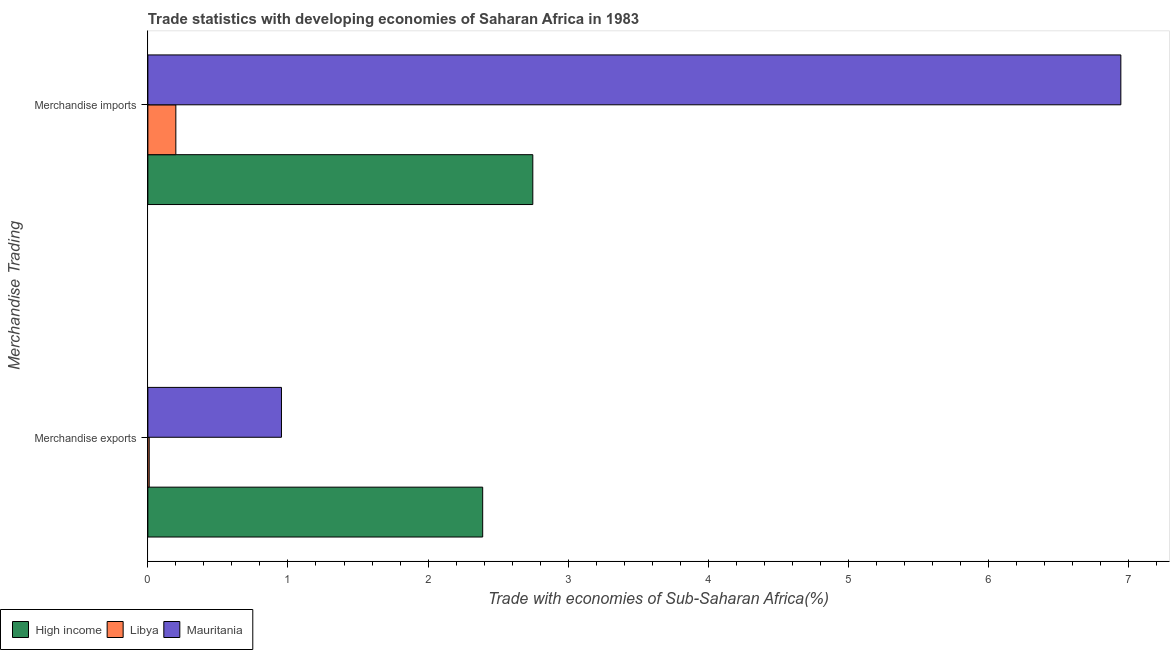How many groups of bars are there?
Give a very brief answer. 2. Are the number of bars per tick equal to the number of legend labels?
Give a very brief answer. Yes. Are the number of bars on each tick of the Y-axis equal?
Provide a succinct answer. Yes. How many bars are there on the 1st tick from the bottom?
Offer a terse response. 3. What is the merchandise imports in Libya?
Provide a short and direct response. 0.2. Across all countries, what is the maximum merchandise exports?
Make the answer very short. 2.39. Across all countries, what is the minimum merchandise exports?
Your answer should be very brief. 0.01. In which country was the merchandise exports maximum?
Offer a very short reply. High income. In which country was the merchandise imports minimum?
Ensure brevity in your answer.  Libya. What is the total merchandise exports in the graph?
Offer a very short reply. 3.35. What is the difference between the merchandise exports in Libya and that in Mauritania?
Provide a short and direct response. -0.94. What is the difference between the merchandise imports in High income and the merchandise exports in Libya?
Give a very brief answer. 2.74. What is the average merchandise exports per country?
Offer a very short reply. 1.12. What is the difference between the merchandise imports and merchandise exports in Libya?
Your answer should be compact. 0.19. In how many countries, is the merchandise imports greater than 2 %?
Provide a succinct answer. 2. What is the ratio of the merchandise imports in Mauritania to that in High income?
Keep it short and to the point. 2.53. In how many countries, is the merchandise imports greater than the average merchandise imports taken over all countries?
Your response must be concise. 1. What does the 3rd bar from the top in Merchandise imports represents?
Offer a very short reply. High income. What does the 2nd bar from the bottom in Merchandise exports represents?
Ensure brevity in your answer.  Libya. What is the difference between two consecutive major ticks on the X-axis?
Give a very brief answer. 1. Are the values on the major ticks of X-axis written in scientific E-notation?
Your answer should be very brief. No. Does the graph contain any zero values?
Ensure brevity in your answer.  No. Does the graph contain grids?
Your answer should be compact. No. What is the title of the graph?
Offer a very short reply. Trade statistics with developing economies of Saharan Africa in 1983. Does "Israel" appear as one of the legend labels in the graph?
Offer a terse response. No. What is the label or title of the X-axis?
Ensure brevity in your answer.  Trade with economies of Sub-Saharan Africa(%). What is the label or title of the Y-axis?
Give a very brief answer. Merchandise Trading. What is the Trade with economies of Sub-Saharan Africa(%) of High income in Merchandise exports?
Your response must be concise. 2.39. What is the Trade with economies of Sub-Saharan Africa(%) in Libya in Merchandise exports?
Your answer should be compact. 0.01. What is the Trade with economies of Sub-Saharan Africa(%) of Mauritania in Merchandise exports?
Your answer should be compact. 0.95. What is the Trade with economies of Sub-Saharan Africa(%) in High income in Merchandise imports?
Give a very brief answer. 2.75. What is the Trade with economies of Sub-Saharan Africa(%) in Libya in Merchandise imports?
Ensure brevity in your answer.  0.2. What is the Trade with economies of Sub-Saharan Africa(%) of Mauritania in Merchandise imports?
Give a very brief answer. 6.94. Across all Merchandise Trading, what is the maximum Trade with economies of Sub-Saharan Africa(%) in High income?
Offer a very short reply. 2.75. Across all Merchandise Trading, what is the maximum Trade with economies of Sub-Saharan Africa(%) in Libya?
Offer a terse response. 0.2. Across all Merchandise Trading, what is the maximum Trade with economies of Sub-Saharan Africa(%) in Mauritania?
Your answer should be compact. 6.94. Across all Merchandise Trading, what is the minimum Trade with economies of Sub-Saharan Africa(%) of High income?
Your response must be concise. 2.39. Across all Merchandise Trading, what is the minimum Trade with economies of Sub-Saharan Africa(%) of Libya?
Provide a succinct answer. 0.01. Across all Merchandise Trading, what is the minimum Trade with economies of Sub-Saharan Africa(%) in Mauritania?
Provide a succinct answer. 0.95. What is the total Trade with economies of Sub-Saharan Africa(%) in High income in the graph?
Your answer should be compact. 5.14. What is the total Trade with economies of Sub-Saharan Africa(%) in Libya in the graph?
Offer a terse response. 0.21. What is the total Trade with economies of Sub-Saharan Africa(%) in Mauritania in the graph?
Give a very brief answer. 7.9. What is the difference between the Trade with economies of Sub-Saharan Africa(%) in High income in Merchandise exports and that in Merchandise imports?
Keep it short and to the point. -0.36. What is the difference between the Trade with economies of Sub-Saharan Africa(%) in Libya in Merchandise exports and that in Merchandise imports?
Make the answer very short. -0.19. What is the difference between the Trade with economies of Sub-Saharan Africa(%) in Mauritania in Merchandise exports and that in Merchandise imports?
Offer a terse response. -5.99. What is the difference between the Trade with economies of Sub-Saharan Africa(%) in High income in Merchandise exports and the Trade with economies of Sub-Saharan Africa(%) in Libya in Merchandise imports?
Ensure brevity in your answer.  2.19. What is the difference between the Trade with economies of Sub-Saharan Africa(%) of High income in Merchandise exports and the Trade with economies of Sub-Saharan Africa(%) of Mauritania in Merchandise imports?
Provide a succinct answer. -4.56. What is the difference between the Trade with economies of Sub-Saharan Africa(%) of Libya in Merchandise exports and the Trade with economies of Sub-Saharan Africa(%) of Mauritania in Merchandise imports?
Provide a short and direct response. -6.94. What is the average Trade with economies of Sub-Saharan Africa(%) in High income per Merchandise Trading?
Your answer should be compact. 2.57. What is the average Trade with economies of Sub-Saharan Africa(%) in Libya per Merchandise Trading?
Provide a succinct answer. 0.1. What is the average Trade with economies of Sub-Saharan Africa(%) in Mauritania per Merchandise Trading?
Provide a short and direct response. 3.95. What is the difference between the Trade with economies of Sub-Saharan Africa(%) of High income and Trade with economies of Sub-Saharan Africa(%) of Libya in Merchandise exports?
Give a very brief answer. 2.38. What is the difference between the Trade with economies of Sub-Saharan Africa(%) of High income and Trade with economies of Sub-Saharan Africa(%) of Mauritania in Merchandise exports?
Your answer should be compact. 1.44. What is the difference between the Trade with economies of Sub-Saharan Africa(%) in Libya and Trade with economies of Sub-Saharan Africa(%) in Mauritania in Merchandise exports?
Provide a short and direct response. -0.94. What is the difference between the Trade with economies of Sub-Saharan Africa(%) of High income and Trade with economies of Sub-Saharan Africa(%) of Libya in Merchandise imports?
Your answer should be compact. 2.55. What is the difference between the Trade with economies of Sub-Saharan Africa(%) of High income and Trade with economies of Sub-Saharan Africa(%) of Mauritania in Merchandise imports?
Your answer should be very brief. -4.2. What is the difference between the Trade with economies of Sub-Saharan Africa(%) of Libya and Trade with economies of Sub-Saharan Africa(%) of Mauritania in Merchandise imports?
Provide a short and direct response. -6.75. What is the ratio of the Trade with economies of Sub-Saharan Africa(%) of High income in Merchandise exports to that in Merchandise imports?
Your answer should be very brief. 0.87. What is the ratio of the Trade with economies of Sub-Saharan Africa(%) in Libya in Merchandise exports to that in Merchandise imports?
Your answer should be compact. 0.05. What is the ratio of the Trade with economies of Sub-Saharan Africa(%) in Mauritania in Merchandise exports to that in Merchandise imports?
Offer a terse response. 0.14. What is the difference between the highest and the second highest Trade with economies of Sub-Saharan Africa(%) in High income?
Provide a succinct answer. 0.36. What is the difference between the highest and the second highest Trade with economies of Sub-Saharan Africa(%) in Libya?
Your answer should be compact. 0.19. What is the difference between the highest and the second highest Trade with economies of Sub-Saharan Africa(%) in Mauritania?
Give a very brief answer. 5.99. What is the difference between the highest and the lowest Trade with economies of Sub-Saharan Africa(%) in High income?
Your response must be concise. 0.36. What is the difference between the highest and the lowest Trade with economies of Sub-Saharan Africa(%) in Libya?
Provide a succinct answer. 0.19. What is the difference between the highest and the lowest Trade with economies of Sub-Saharan Africa(%) of Mauritania?
Give a very brief answer. 5.99. 